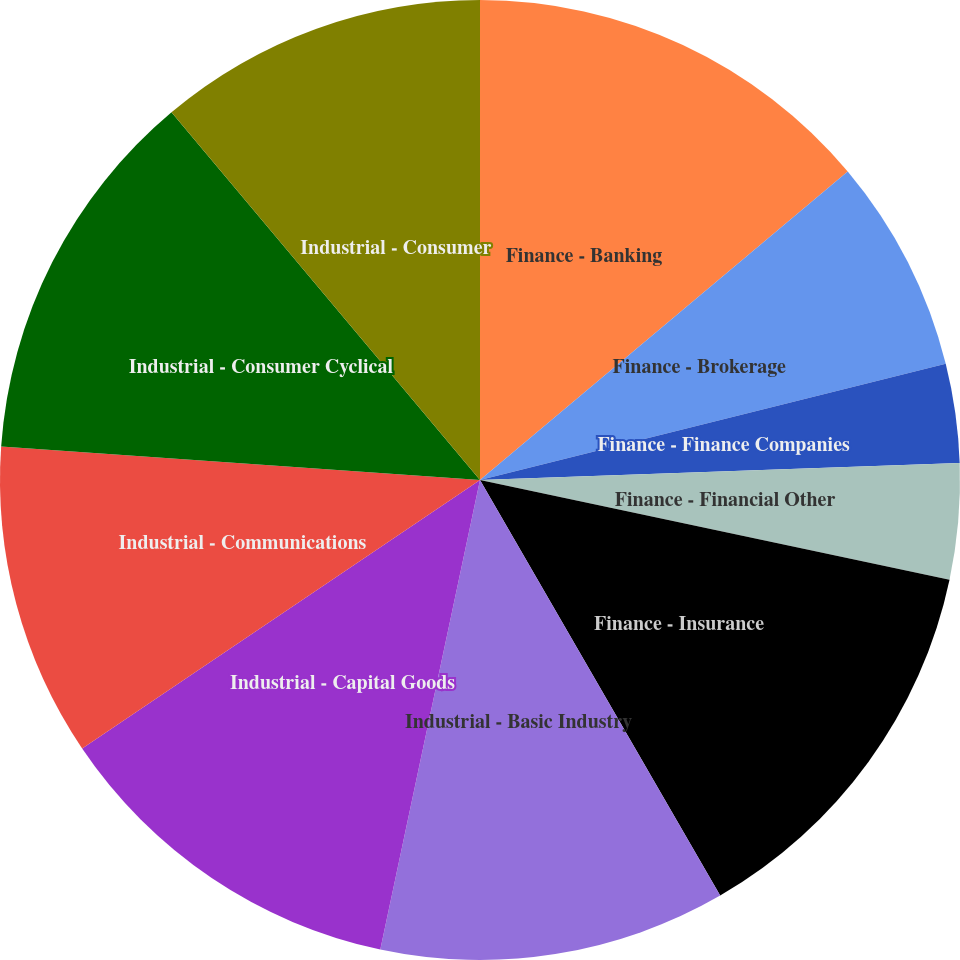<chart> <loc_0><loc_0><loc_500><loc_500><pie_chart><fcel>Finance - Banking<fcel>Finance - Brokerage<fcel>Finance - Finance Companies<fcel>Finance - Financial Other<fcel>Finance - Insurance<fcel>Industrial - Basic Industry<fcel>Industrial - Capital Goods<fcel>Industrial - Communications<fcel>Industrial - Consumer Cyclical<fcel>Industrial - Consumer<nl><fcel>13.89%<fcel>7.22%<fcel>3.33%<fcel>3.89%<fcel>13.33%<fcel>11.67%<fcel>12.22%<fcel>10.56%<fcel>12.78%<fcel>11.11%<nl></chart> 